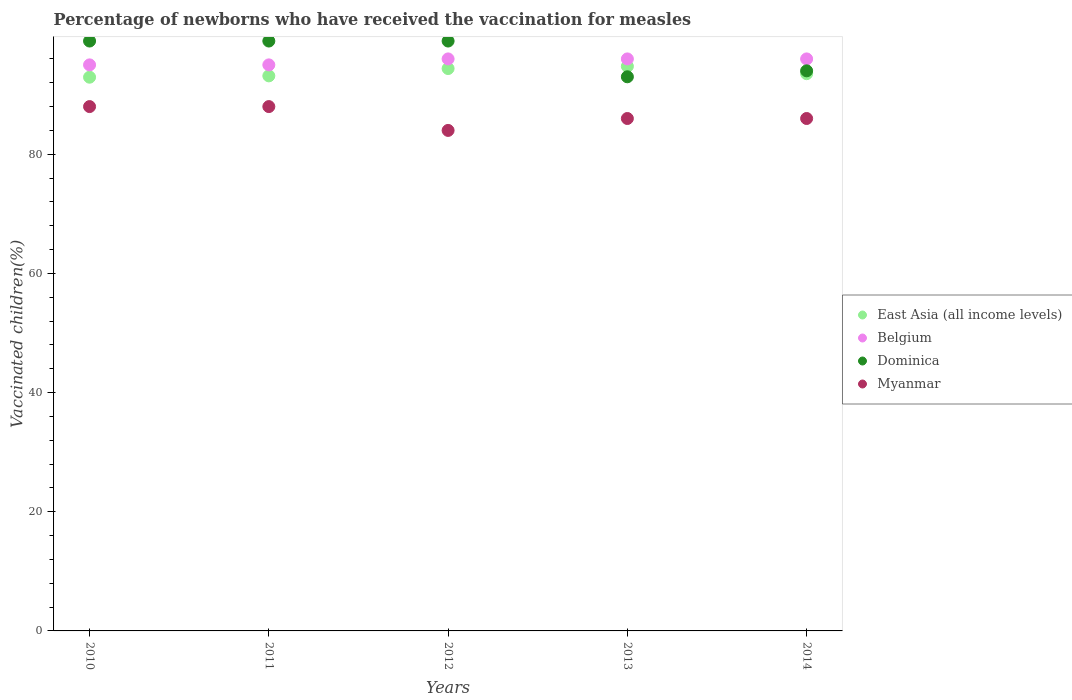Across all years, what is the maximum percentage of vaccinated children in Belgium?
Your answer should be compact. 96. What is the total percentage of vaccinated children in Belgium in the graph?
Your answer should be compact. 478. What is the difference between the percentage of vaccinated children in Myanmar in 2013 and the percentage of vaccinated children in East Asia (all income levels) in 2010?
Provide a succinct answer. -6.93. What is the average percentage of vaccinated children in Belgium per year?
Provide a short and direct response. 95.6. In the year 2012, what is the difference between the percentage of vaccinated children in Dominica and percentage of vaccinated children in Belgium?
Ensure brevity in your answer.  3. What is the ratio of the percentage of vaccinated children in East Asia (all income levels) in 2010 to that in 2014?
Provide a short and direct response. 0.99. Is the percentage of vaccinated children in Belgium in 2010 less than that in 2013?
Provide a short and direct response. Yes. What is the difference between the highest and the second highest percentage of vaccinated children in Dominica?
Your answer should be very brief. 0. What is the difference between the highest and the lowest percentage of vaccinated children in East Asia (all income levels)?
Offer a terse response. 1.82. Is it the case that in every year, the sum of the percentage of vaccinated children in Myanmar and percentage of vaccinated children in East Asia (all income levels)  is greater than the percentage of vaccinated children in Dominica?
Offer a terse response. Yes. Does the percentage of vaccinated children in Dominica monotonically increase over the years?
Offer a terse response. No. Is the percentage of vaccinated children in Myanmar strictly greater than the percentage of vaccinated children in Belgium over the years?
Ensure brevity in your answer.  No. Is the percentage of vaccinated children in Belgium strictly less than the percentage of vaccinated children in Myanmar over the years?
Offer a terse response. No. How many years are there in the graph?
Your answer should be compact. 5. Are the values on the major ticks of Y-axis written in scientific E-notation?
Provide a succinct answer. No. Does the graph contain any zero values?
Ensure brevity in your answer.  No. Where does the legend appear in the graph?
Your answer should be compact. Center right. What is the title of the graph?
Keep it short and to the point. Percentage of newborns who have received the vaccination for measles. What is the label or title of the Y-axis?
Your answer should be very brief. Vaccinated children(%). What is the Vaccinated children(%) of East Asia (all income levels) in 2010?
Your answer should be very brief. 92.93. What is the Vaccinated children(%) of Belgium in 2010?
Your answer should be compact. 95. What is the Vaccinated children(%) in East Asia (all income levels) in 2011?
Keep it short and to the point. 93.15. What is the Vaccinated children(%) of Myanmar in 2011?
Offer a terse response. 88. What is the Vaccinated children(%) in East Asia (all income levels) in 2012?
Your answer should be compact. 94.38. What is the Vaccinated children(%) in Belgium in 2012?
Give a very brief answer. 96. What is the Vaccinated children(%) in Myanmar in 2012?
Your response must be concise. 84. What is the Vaccinated children(%) in East Asia (all income levels) in 2013?
Make the answer very short. 94.76. What is the Vaccinated children(%) in Belgium in 2013?
Keep it short and to the point. 96. What is the Vaccinated children(%) of Dominica in 2013?
Your response must be concise. 93. What is the Vaccinated children(%) of East Asia (all income levels) in 2014?
Your answer should be compact. 93.52. What is the Vaccinated children(%) in Belgium in 2014?
Keep it short and to the point. 96. What is the Vaccinated children(%) of Dominica in 2014?
Your answer should be compact. 94. What is the Vaccinated children(%) of Myanmar in 2014?
Offer a terse response. 86. Across all years, what is the maximum Vaccinated children(%) of East Asia (all income levels)?
Your answer should be very brief. 94.76. Across all years, what is the maximum Vaccinated children(%) in Belgium?
Make the answer very short. 96. Across all years, what is the minimum Vaccinated children(%) in East Asia (all income levels)?
Provide a short and direct response. 92.93. Across all years, what is the minimum Vaccinated children(%) of Belgium?
Offer a terse response. 95. Across all years, what is the minimum Vaccinated children(%) in Dominica?
Your answer should be very brief. 93. Across all years, what is the minimum Vaccinated children(%) of Myanmar?
Your answer should be very brief. 84. What is the total Vaccinated children(%) in East Asia (all income levels) in the graph?
Provide a short and direct response. 468.75. What is the total Vaccinated children(%) of Belgium in the graph?
Ensure brevity in your answer.  478. What is the total Vaccinated children(%) of Dominica in the graph?
Make the answer very short. 484. What is the total Vaccinated children(%) in Myanmar in the graph?
Your response must be concise. 432. What is the difference between the Vaccinated children(%) of East Asia (all income levels) in 2010 and that in 2011?
Your answer should be very brief. -0.22. What is the difference between the Vaccinated children(%) in East Asia (all income levels) in 2010 and that in 2012?
Keep it short and to the point. -1.45. What is the difference between the Vaccinated children(%) of Belgium in 2010 and that in 2012?
Your answer should be very brief. -1. What is the difference between the Vaccinated children(%) in Myanmar in 2010 and that in 2012?
Make the answer very short. 4. What is the difference between the Vaccinated children(%) in East Asia (all income levels) in 2010 and that in 2013?
Give a very brief answer. -1.82. What is the difference between the Vaccinated children(%) in Belgium in 2010 and that in 2013?
Ensure brevity in your answer.  -1. What is the difference between the Vaccinated children(%) of East Asia (all income levels) in 2010 and that in 2014?
Offer a terse response. -0.59. What is the difference between the Vaccinated children(%) in Belgium in 2010 and that in 2014?
Provide a succinct answer. -1. What is the difference between the Vaccinated children(%) of Myanmar in 2010 and that in 2014?
Give a very brief answer. 2. What is the difference between the Vaccinated children(%) in East Asia (all income levels) in 2011 and that in 2012?
Your answer should be compact. -1.23. What is the difference between the Vaccinated children(%) in Dominica in 2011 and that in 2012?
Keep it short and to the point. 0. What is the difference between the Vaccinated children(%) in East Asia (all income levels) in 2011 and that in 2013?
Provide a short and direct response. -1.6. What is the difference between the Vaccinated children(%) in Myanmar in 2011 and that in 2013?
Give a very brief answer. 2. What is the difference between the Vaccinated children(%) in East Asia (all income levels) in 2011 and that in 2014?
Give a very brief answer. -0.37. What is the difference between the Vaccinated children(%) of Dominica in 2011 and that in 2014?
Ensure brevity in your answer.  5. What is the difference between the Vaccinated children(%) in East Asia (all income levels) in 2012 and that in 2013?
Offer a very short reply. -0.37. What is the difference between the Vaccinated children(%) in Belgium in 2012 and that in 2013?
Provide a succinct answer. 0. What is the difference between the Vaccinated children(%) in Myanmar in 2012 and that in 2013?
Provide a short and direct response. -2. What is the difference between the Vaccinated children(%) of East Asia (all income levels) in 2012 and that in 2014?
Keep it short and to the point. 0.86. What is the difference between the Vaccinated children(%) in Dominica in 2012 and that in 2014?
Give a very brief answer. 5. What is the difference between the Vaccinated children(%) of Myanmar in 2012 and that in 2014?
Provide a succinct answer. -2. What is the difference between the Vaccinated children(%) of East Asia (all income levels) in 2013 and that in 2014?
Keep it short and to the point. 1.23. What is the difference between the Vaccinated children(%) of East Asia (all income levels) in 2010 and the Vaccinated children(%) of Belgium in 2011?
Provide a succinct answer. -2.07. What is the difference between the Vaccinated children(%) of East Asia (all income levels) in 2010 and the Vaccinated children(%) of Dominica in 2011?
Offer a very short reply. -6.07. What is the difference between the Vaccinated children(%) in East Asia (all income levels) in 2010 and the Vaccinated children(%) in Myanmar in 2011?
Offer a terse response. 4.93. What is the difference between the Vaccinated children(%) of Dominica in 2010 and the Vaccinated children(%) of Myanmar in 2011?
Your answer should be compact. 11. What is the difference between the Vaccinated children(%) of East Asia (all income levels) in 2010 and the Vaccinated children(%) of Belgium in 2012?
Provide a succinct answer. -3.07. What is the difference between the Vaccinated children(%) in East Asia (all income levels) in 2010 and the Vaccinated children(%) in Dominica in 2012?
Keep it short and to the point. -6.07. What is the difference between the Vaccinated children(%) of East Asia (all income levels) in 2010 and the Vaccinated children(%) of Myanmar in 2012?
Offer a very short reply. 8.93. What is the difference between the Vaccinated children(%) in Belgium in 2010 and the Vaccinated children(%) in Myanmar in 2012?
Give a very brief answer. 11. What is the difference between the Vaccinated children(%) in East Asia (all income levels) in 2010 and the Vaccinated children(%) in Belgium in 2013?
Your answer should be very brief. -3.07. What is the difference between the Vaccinated children(%) in East Asia (all income levels) in 2010 and the Vaccinated children(%) in Dominica in 2013?
Make the answer very short. -0.07. What is the difference between the Vaccinated children(%) in East Asia (all income levels) in 2010 and the Vaccinated children(%) in Myanmar in 2013?
Give a very brief answer. 6.93. What is the difference between the Vaccinated children(%) of Belgium in 2010 and the Vaccinated children(%) of Dominica in 2013?
Your answer should be compact. 2. What is the difference between the Vaccinated children(%) in Belgium in 2010 and the Vaccinated children(%) in Myanmar in 2013?
Offer a terse response. 9. What is the difference between the Vaccinated children(%) in East Asia (all income levels) in 2010 and the Vaccinated children(%) in Belgium in 2014?
Give a very brief answer. -3.07. What is the difference between the Vaccinated children(%) in East Asia (all income levels) in 2010 and the Vaccinated children(%) in Dominica in 2014?
Keep it short and to the point. -1.07. What is the difference between the Vaccinated children(%) of East Asia (all income levels) in 2010 and the Vaccinated children(%) of Myanmar in 2014?
Make the answer very short. 6.93. What is the difference between the Vaccinated children(%) of Belgium in 2010 and the Vaccinated children(%) of Dominica in 2014?
Offer a very short reply. 1. What is the difference between the Vaccinated children(%) of East Asia (all income levels) in 2011 and the Vaccinated children(%) of Belgium in 2012?
Offer a very short reply. -2.85. What is the difference between the Vaccinated children(%) of East Asia (all income levels) in 2011 and the Vaccinated children(%) of Dominica in 2012?
Make the answer very short. -5.84. What is the difference between the Vaccinated children(%) of East Asia (all income levels) in 2011 and the Vaccinated children(%) of Myanmar in 2012?
Offer a terse response. 9.15. What is the difference between the Vaccinated children(%) of Belgium in 2011 and the Vaccinated children(%) of Dominica in 2012?
Your response must be concise. -4. What is the difference between the Vaccinated children(%) in Belgium in 2011 and the Vaccinated children(%) in Myanmar in 2012?
Provide a succinct answer. 11. What is the difference between the Vaccinated children(%) of Dominica in 2011 and the Vaccinated children(%) of Myanmar in 2012?
Make the answer very short. 15. What is the difference between the Vaccinated children(%) in East Asia (all income levels) in 2011 and the Vaccinated children(%) in Belgium in 2013?
Provide a short and direct response. -2.85. What is the difference between the Vaccinated children(%) of East Asia (all income levels) in 2011 and the Vaccinated children(%) of Dominica in 2013?
Make the answer very short. 0.15. What is the difference between the Vaccinated children(%) of East Asia (all income levels) in 2011 and the Vaccinated children(%) of Myanmar in 2013?
Provide a short and direct response. 7.16. What is the difference between the Vaccinated children(%) in Belgium in 2011 and the Vaccinated children(%) in Dominica in 2013?
Provide a short and direct response. 2. What is the difference between the Vaccinated children(%) in Belgium in 2011 and the Vaccinated children(%) in Myanmar in 2013?
Provide a succinct answer. 9. What is the difference between the Vaccinated children(%) in Dominica in 2011 and the Vaccinated children(%) in Myanmar in 2013?
Offer a terse response. 13. What is the difference between the Vaccinated children(%) of East Asia (all income levels) in 2011 and the Vaccinated children(%) of Belgium in 2014?
Offer a terse response. -2.85. What is the difference between the Vaccinated children(%) in East Asia (all income levels) in 2011 and the Vaccinated children(%) in Dominica in 2014?
Your answer should be compact. -0.84. What is the difference between the Vaccinated children(%) of East Asia (all income levels) in 2011 and the Vaccinated children(%) of Myanmar in 2014?
Offer a very short reply. 7.16. What is the difference between the Vaccinated children(%) of Belgium in 2011 and the Vaccinated children(%) of Dominica in 2014?
Offer a very short reply. 1. What is the difference between the Vaccinated children(%) of Belgium in 2011 and the Vaccinated children(%) of Myanmar in 2014?
Your answer should be compact. 9. What is the difference between the Vaccinated children(%) of East Asia (all income levels) in 2012 and the Vaccinated children(%) of Belgium in 2013?
Make the answer very short. -1.62. What is the difference between the Vaccinated children(%) in East Asia (all income levels) in 2012 and the Vaccinated children(%) in Dominica in 2013?
Give a very brief answer. 1.38. What is the difference between the Vaccinated children(%) of East Asia (all income levels) in 2012 and the Vaccinated children(%) of Myanmar in 2013?
Your response must be concise. 8.38. What is the difference between the Vaccinated children(%) of East Asia (all income levels) in 2012 and the Vaccinated children(%) of Belgium in 2014?
Your answer should be very brief. -1.62. What is the difference between the Vaccinated children(%) in East Asia (all income levels) in 2012 and the Vaccinated children(%) in Dominica in 2014?
Your response must be concise. 0.38. What is the difference between the Vaccinated children(%) of East Asia (all income levels) in 2012 and the Vaccinated children(%) of Myanmar in 2014?
Make the answer very short. 8.38. What is the difference between the Vaccinated children(%) in Belgium in 2012 and the Vaccinated children(%) in Dominica in 2014?
Your response must be concise. 2. What is the difference between the Vaccinated children(%) in Dominica in 2012 and the Vaccinated children(%) in Myanmar in 2014?
Ensure brevity in your answer.  13. What is the difference between the Vaccinated children(%) in East Asia (all income levels) in 2013 and the Vaccinated children(%) in Belgium in 2014?
Give a very brief answer. -1.24. What is the difference between the Vaccinated children(%) of East Asia (all income levels) in 2013 and the Vaccinated children(%) of Dominica in 2014?
Give a very brief answer. 0.76. What is the difference between the Vaccinated children(%) of East Asia (all income levels) in 2013 and the Vaccinated children(%) of Myanmar in 2014?
Your answer should be compact. 8.76. What is the difference between the Vaccinated children(%) of Belgium in 2013 and the Vaccinated children(%) of Dominica in 2014?
Provide a short and direct response. 2. What is the difference between the Vaccinated children(%) in Belgium in 2013 and the Vaccinated children(%) in Myanmar in 2014?
Your answer should be very brief. 10. What is the difference between the Vaccinated children(%) in Dominica in 2013 and the Vaccinated children(%) in Myanmar in 2014?
Offer a terse response. 7. What is the average Vaccinated children(%) of East Asia (all income levels) per year?
Offer a very short reply. 93.75. What is the average Vaccinated children(%) in Belgium per year?
Keep it short and to the point. 95.6. What is the average Vaccinated children(%) of Dominica per year?
Offer a terse response. 96.8. What is the average Vaccinated children(%) in Myanmar per year?
Offer a terse response. 86.4. In the year 2010, what is the difference between the Vaccinated children(%) of East Asia (all income levels) and Vaccinated children(%) of Belgium?
Offer a terse response. -2.07. In the year 2010, what is the difference between the Vaccinated children(%) of East Asia (all income levels) and Vaccinated children(%) of Dominica?
Offer a very short reply. -6.07. In the year 2010, what is the difference between the Vaccinated children(%) in East Asia (all income levels) and Vaccinated children(%) in Myanmar?
Provide a succinct answer. 4.93. In the year 2010, what is the difference between the Vaccinated children(%) in Belgium and Vaccinated children(%) in Dominica?
Offer a terse response. -4. In the year 2010, what is the difference between the Vaccinated children(%) in Dominica and Vaccinated children(%) in Myanmar?
Offer a terse response. 11. In the year 2011, what is the difference between the Vaccinated children(%) of East Asia (all income levels) and Vaccinated children(%) of Belgium?
Keep it short and to the point. -1.84. In the year 2011, what is the difference between the Vaccinated children(%) in East Asia (all income levels) and Vaccinated children(%) in Dominica?
Give a very brief answer. -5.84. In the year 2011, what is the difference between the Vaccinated children(%) of East Asia (all income levels) and Vaccinated children(%) of Myanmar?
Keep it short and to the point. 5.16. In the year 2011, what is the difference between the Vaccinated children(%) of Belgium and Vaccinated children(%) of Dominica?
Offer a very short reply. -4. In the year 2011, what is the difference between the Vaccinated children(%) of Belgium and Vaccinated children(%) of Myanmar?
Give a very brief answer. 7. In the year 2011, what is the difference between the Vaccinated children(%) in Dominica and Vaccinated children(%) in Myanmar?
Your answer should be compact. 11. In the year 2012, what is the difference between the Vaccinated children(%) in East Asia (all income levels) and Vaccinated children(%) in Belgium?
Give a very brief answer. -1.62. In the year 2012, what is the difference between the Vaccinated children(%) in East Asia (all income levels) and Vaccinated children(%) in Dominica?
Your answer should be compact. -4.62. In the year 2012, what is the difference between the Vaccinated children(%) in East Asia (all income levels) and Vaccinated children(%) in Myanmar?
Offer a terse response. 10.38. In the year 2012, what is the difference between the Vaccinated children(%) of Belgium and Vaccinated children(%) of Dominica?
Make the answer very short. -3. In the year 2012, what is the difference between the Vaccinated children(%) in Belgium and Vaccinated children(%) in Myanmar?
Your answer should be compact. 12. In the year 2012, what is the difference between the Vaccinated children(%) in Dominica and Vaccinated children(%) in Myanmar?
Provide a succinct answer. 15. In the year 2013, what is the difference between the Vaccinated children(%) of East Asia (all income levels) and Vaccinated children(%) of Belgium?
Offer a terse response. -1.24. In the year 2013, what is the difference between the Vaccinated children(%) of East Asia (all income levels) and Vaccinated children(%) of Dominica?
Offer a very short reply. 1.76. In the year 2013, what is the difference between the Vaccinated children(%) of East Asia (all income levels) and Vaccinated children(%) of Myanmar?
Make the answer very short. 8.76. In the year 2013, what is the difference between the Vaccinated children(%) in Belgium and Vaccinated children(%) in Myanmar?
Ensure brevity in your answer.  10. In the year 2013, what is the difference between the Vaccinated children(%) of Dominica and Vaccinated children(%) of Myanmar?
Offer a terse response. 7. In the year 2014, what is the difference between the Vaccinated children(%) of East Asia (all income levels) and Vaccinated children(%) of Belgium?
Make the answer very short. -2.48. In the year 2014, what is the difference between the Vaccinated children(%) in East Asia (all income levels) and Vaccinated children(%) in Dominica?
Give a very brief answer. -0.48. In the year 2014, what is the difference between the Vaccinated children(%) in East Asia (all income levels) and Vaccinated children(%) in Myanmar?
Ensure brevity in your answer.  7.52. In the year 2014, what is the difference between the Vaccinated children(%) of Belgium and Vaccinated children(%) of Dominica?
Your response must be concise. 2. In the year 2014, what is the difference between the Vaccinated children(%) of Dominica and Vaccinated children(%) of Myanmar?
Provide a short and direct response. 8. What is the ratio of the Vaccinated children(%) of East Asia (all income levels) in 2010 to that in 2011?
Your answer should be very brief. 1. What is the ratio of the Vaccinated children(%) of Belgium in 2010 to that in 2011?
Make the answer very short. 1. What is the ratio of the Vaccinated children(%) of Dominica in 2010 to that in 2011?
Provide a succinct answer. 1. What is the ratio of the Vaccinated children(%) in East Asia (all income levels) in 2010 to that in 2012?
Provide a short and direct response. 0.98. What is the ratio of the Vaccinated children(%) of Dominica in 2010 to that in 2012?
Make the answer very short. 1. What is the ratio of the Vaccinated children(%) of Myanmar in 2010 to that in 2012?
Ensure brevity in your answer.  1.05. What is the ratio of the Vaccinated children(%) in East Asia (all income levels) in 2010 to that in 2013?
Offer a terse response. 0.98. What is the ratio of the Vaccinated children(%) in Belgium in 2010 to that in 2013?
Provide a short and direct response. 0.99. What is the ratio of the Vaccinated children(%) in Dominica in 2010 to that in 2013?
Your answer should be compact. 1.06. What is the ratio of the Vaccinated children(%) of Myanmar in 2010 to that in 2013?
Make the answer very short. 1.02. What is the ratio of the Vaccinated children(%) of East Asia (all income levels) in 2010 to that in 2014?
Offer a terse response. 0.99. What is the ratio of the Vaccinated children(%) in Belgium in 2010 to that in 2014?
Your answer should be compact. 0.99. What is the ratio of the Vaccinated children(%) of Dominica in 2010 to that in 2014?
Offer a very short reply. 1.05. What is the ratio of the Vaccinated children(%) of Myanmar in 2010 to that in 2014?
Make the answer very short. 1.02. What is the ratio of the Vaccinated children(%) of Myanmar in 2011 to that in 2012?
Make the answer very short. 1.05. What is the ratio of the Vaccinated children(%) in East Asia (all income levels) in 2011 to that in 2013?
Offer a terse response. 0.98. What is the ratio of the Vaccinated children(%) of Belgium in 2011 to that in 2013?
Give a very brief answer. 0.99. What is the ratio of the Vaccinated children(%) in Dominica in 2011 to that in 2013?
Offer a very short reply. 1.06. What is the ratio of the Vaccinated children(%) of Myanmar in 2011 to that in 2013?
Make the answer very short. 1.02. What is the ratio of the Vaccinated children(%) in East Asia (all income levels) in 2011 to that in 2014?
Keep it short and to the point. 1. What is the ratio of the Vaccinated children(%) in Belgium in 2011 to that in 2014?
Provide a short and direct response. 0.99. What is the ratio of the Vaccinated children(%) in Dominica in 2011 to that in 2014?
Offer a terse response. 1.05. What is the ratio of the Vaccinated children(%) in Myanmar in 2011 to that in 2014?
Your answer should be compact. 1.02. What is the ratio of the Vaccinated children(%) in East Asia (all income levels) in 2012 to that in 2013?
Offer a terse response. 1. What is the ratio of the Vaccinated children(%) in Belgium in 2012 to that in 2013?
Keep it short and to the point. 1. What is the ratio of the Vaccinated children(%) in Dominica in 2012 to that in 2013?
Your answer should be very brief. 1.06. What is the ratio of the Vaccinated children(%) in Myanmar in 2012 to that in 2013?
Your response must be concise. 0.98. What is the ratio of the Vaccinated children(%) of East Asia (all income levels) in 2012 to that in 2014?
Your answer should be compact. 1.01. What is the ratio of the Vaccinated children(%) in Belgium in 2012 to that in 2014?
Your response must be concise. 1. What is the ratio of the Vaccinated children(%) in Dominica in 2012 to that in 2014?
Provide a succinct answer. 1.05. What is the ratio of the Vaccinated children(%) of Myanmar in 2012 to that in 2014?
Offer a terse response. 0.98. What is the ratio of the Vaccinated children(%) in East Asia (all income levels) in 2013 to that in 2014?
Give a very brief answer. 1.01. What is the ratio of the Vaccinated children(%) of Dominica in 2013 to that in 2014?
Give a very brief answer. 0.99. What is the difference between the highest and the second highest Vaccinated children(%) of East Asia (all income levels)?
Keep it short and to the point. 0.37. What is the difference between the highest and the lowest Vaccinated children(%) of East Asia (all income levels)?
Your answer should be very brief. 1.82. What is the difference between the highest and the lowest Vaccinated children(%) in Dominica?
Provide a short and direct response. 6. What is the difference between the highest and the lowest Vaccinated children(%) of Myanmar?
Your answer should be compact. 4. 